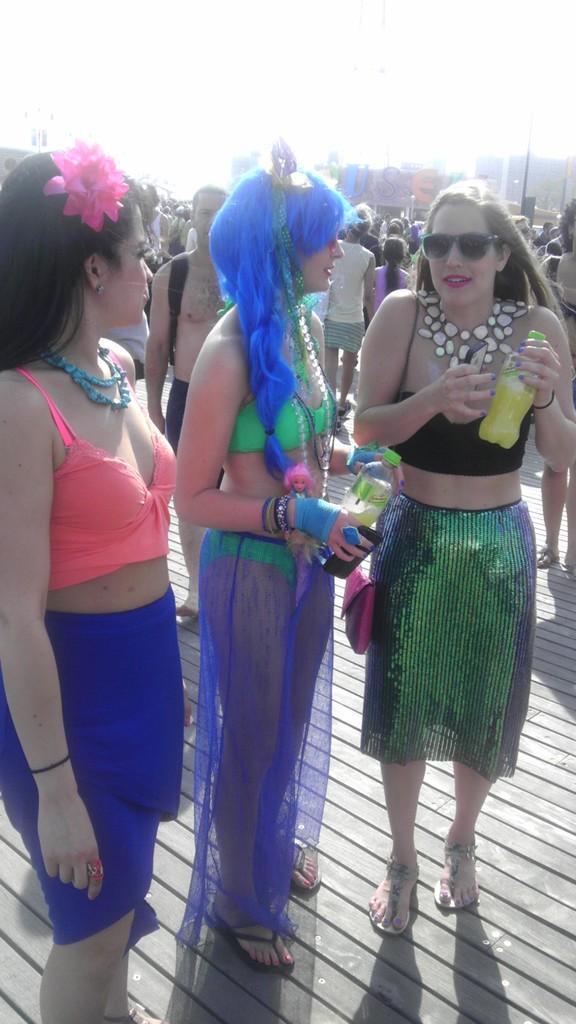In one or two sentences, can you explain what this image depicts? In this image we can see a group of people standing on the floor, two of them are holding bottles and buildings and sky in the background. 